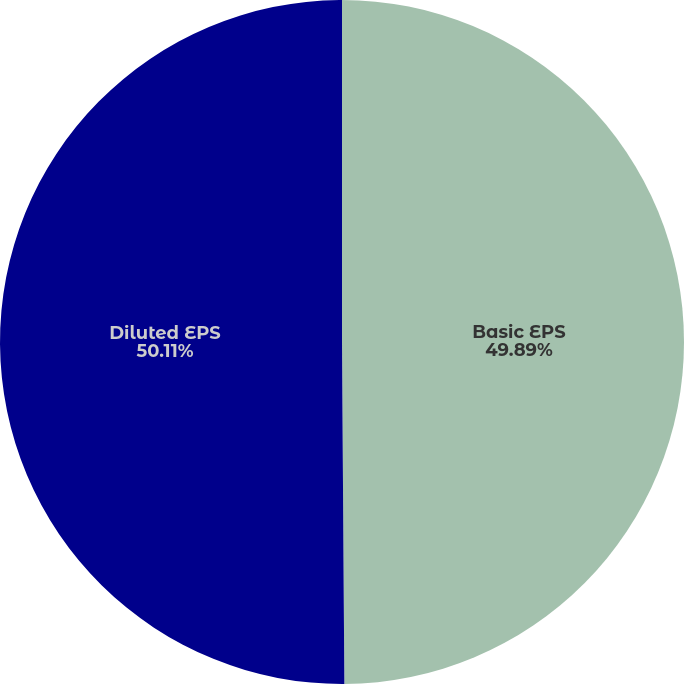Convert chart. <chart><loc_0><loc_0><loc_500><loc_500><pie_chart><fcel>Basic EPS<fcel>Diluted EPS<nl><fcel>49.89%<fcel>50.11%<nl></chart> 